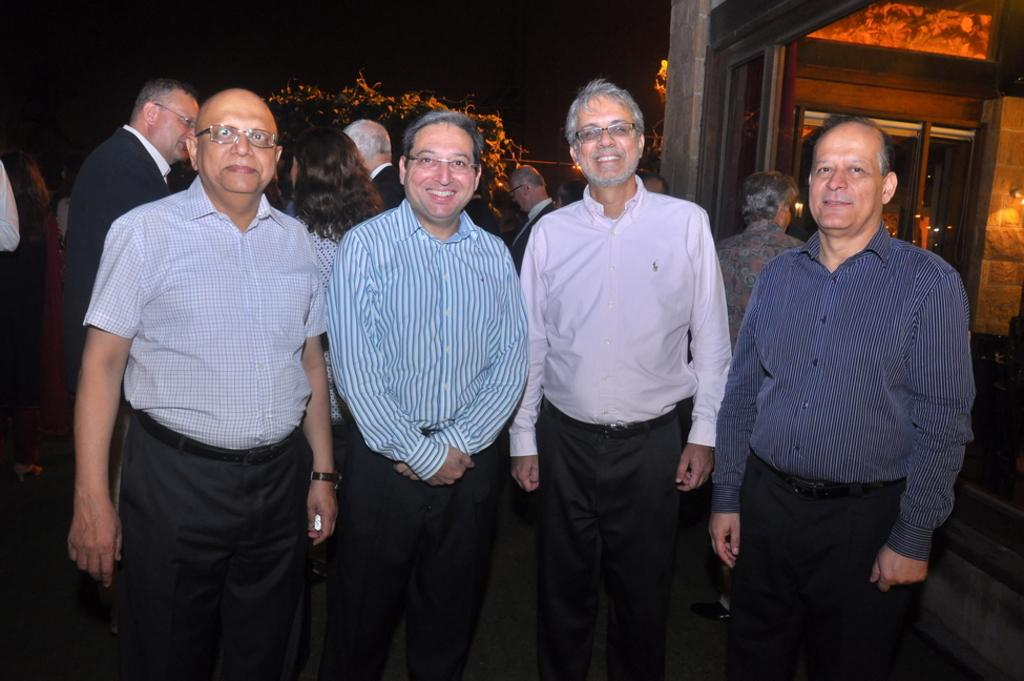How many people are in the group in the image? There are four persons standing and posing in the image. What are the people in the image doing? They are standing and posing. What can be seen in the background of the image? There are trees and a building in the image, and the background is dark. What type of slave can be seen in the image? There is no slave present in the image; it features a group of people standing and posing. What color is the shirt worn by the person in the image? The provided facts do not mention any specific clothing items or colors, so we cannot determine the color of any shirt in the image. 